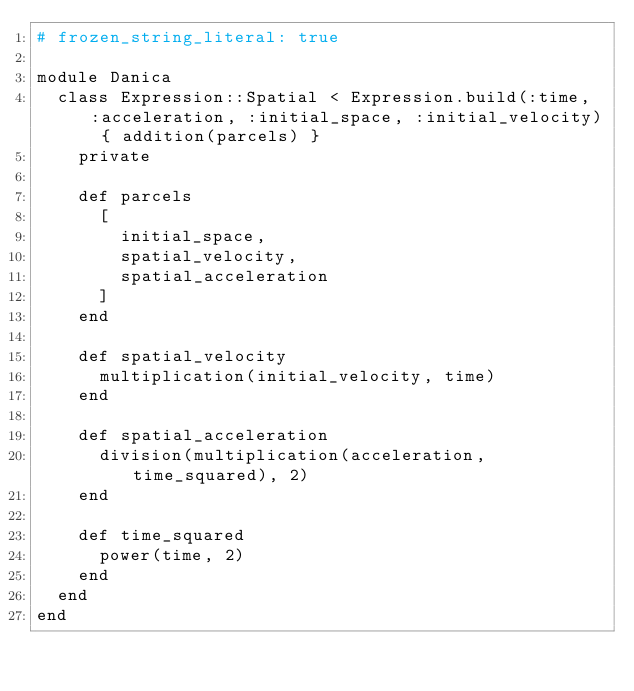<code> <loc_0><loc_0><loc_500><loc_500><_Ruby_># frozen_string_literal: true

module Danica
  class Expression::Spatial < Expression.build(:time, :acceleration, :initial_space, :initial_velocity) { addition(parcels) }
    private

    def parcels
      [
        initial_space,
        spatial_velocity,
        spatial_acceleration
      ]
    end

    def spatial_velocity
      multiplication(initial_velocity, time)
    end

    def spatial_acceleration
      division(multiplication(acceleration, time_squared), 2)
    end

    def time_squared
      power(time, 2)
    end
  end
end
</code> 